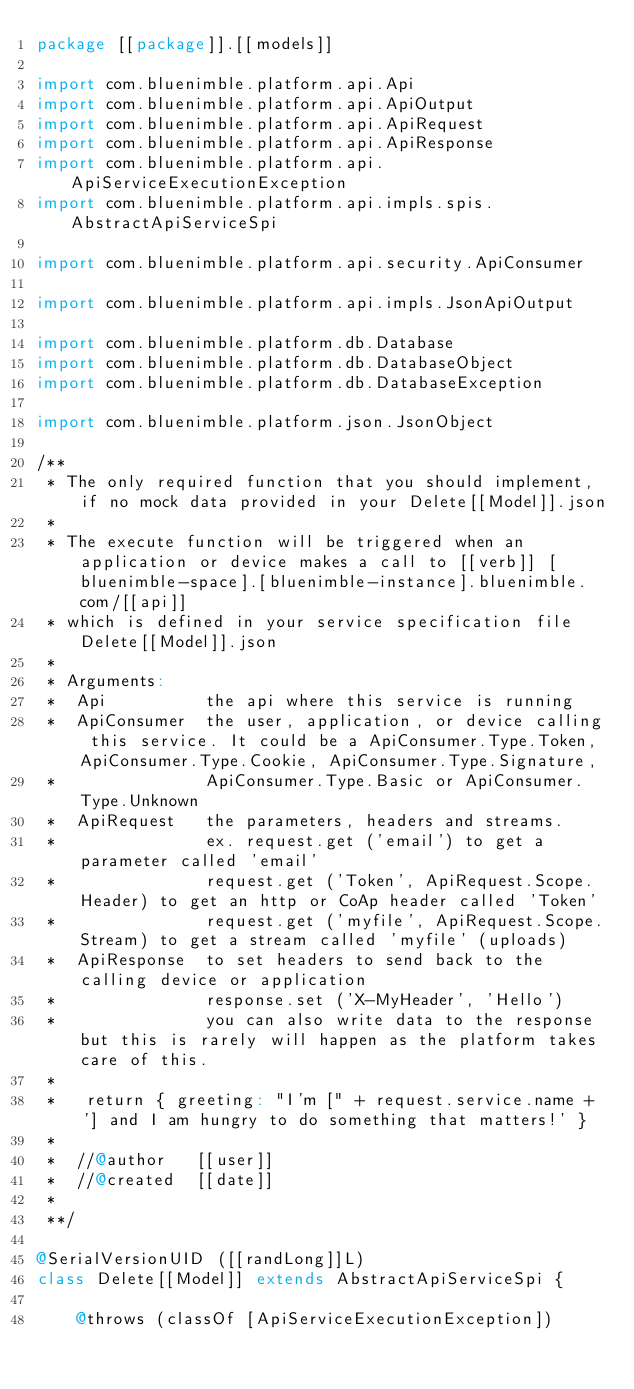<code> <loc_0><loc_0><loc_500><loc_500><_Scala_>package [[package]].[[models]]
	
import com.bluenimble.platform.api.Api
import com.bluenimble.platform.api.ApiOutput
import com.bluenimble.platform.api.ApiRequest
import com.bluenimble.platform.api.ApiResponse
import com.bluenimble.platform.api.ApiServiceExecutionException
import com.bluenimble.platform.api.impls.spis.AbstractApiServiceSpi

import com.bluenimble.platform.api.security.ApiConsumer

import com.bluenimble.platform.api.impls.JsonApiOutput

import com.bluenimble.platform.db.Database
import com.bluenimble.platform.db.DatabaseObject
import com.bluenimble.platform.db.DatabaseException

import com.bluenimble.platform.json.JsonObject

/**
 * The only required function that you should implement, if no mock data provided in your Delete[[Model]].json
 * 
 * The execute function will be triggered when an application or device makes a call to [[verb]] [bluenimble-space].[bluenimble-instance].bluenimble.com/[[api]]
 * which is defined in your service specification file Delete[[Model]].json 
 * 
 * Arguments:
 *  Api 		 the api where this service is running  
 *  ApiConsumer  the user, application, or device calling this service. It could be a ApiConsumer.Type.Token, ApiConsumer.Type.Cookie, ApiConsumer.Type.Signature, 
 *				 ApiConsumer.Type.Basic or ApiConsumer.Type.Unknown
 *  ApiRequest 	 the parameters, headers and streams. 
 *               ex. request.get ('email') to get a parameter called 'email'
 *               request.get ('Token', ApiRequest.Scope.Header) to get an http or CoAp header called 'Token'
 *               request.get ('myfile', ApiRequest.Scope.Stream) to get a stream called 'myfile' (uploads) 
 *  ApiResponse  to set headers to send back to the calling device or application 
 * 				 response.set ('X-MyHeader', 'Hello')
 *				 you can also write data to the response but this is rarely will happen as the platform takes care of this.	
 *   
 *   return { greeting: "I'm [" + request.service.name + '] and I am hungry to do something that matters!' }
 *
 *	//@author	[[user]]
 *	//@created	[[date]]
 * 
 **/

@SerialVersionUID ([[randLong]]L)
class Delete[[Model]] extends AbstractApiServiceSpi {

	@throws (classOf [ApiServiceExecutionException])</code> 